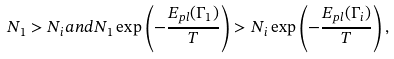<formula> <loc_0><loc_0><loc_500><loc_500>N _ { 1 } > N _ { i } a n d N _ { 1 } \exp \left ( - \frac { E _ { p l } ( \Gamma _ { 1 } ) } { T } \right ) > N _ { i } \exp \left ( - \frac { E _ { p l } ( \Gamma _ { i } ) } { T } \right ) ,</formula> 